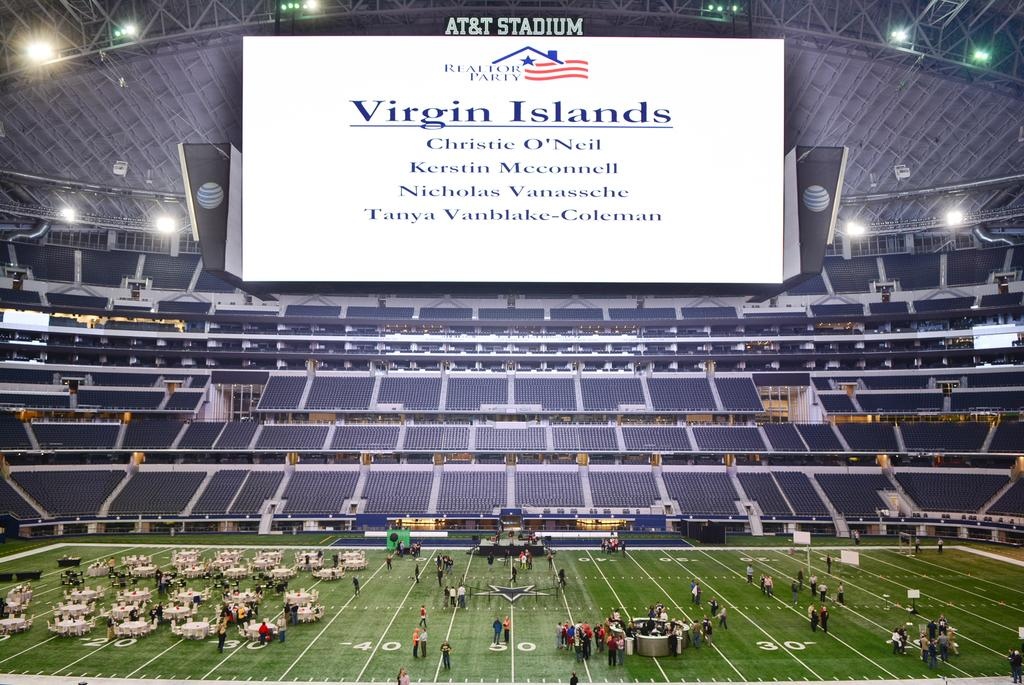Where was the image taken? The image was taken in a ground. What can be seen in the image besides the ground? There are people standing and chairs in the image. What is the white color display at the top of the image? The white color display at the top of the image has "VIRGIN ISLAND" written on it. What type of disease is spreading among the people in the image? There is no indication of any disease in the image; it only shows people standing and chairs. 